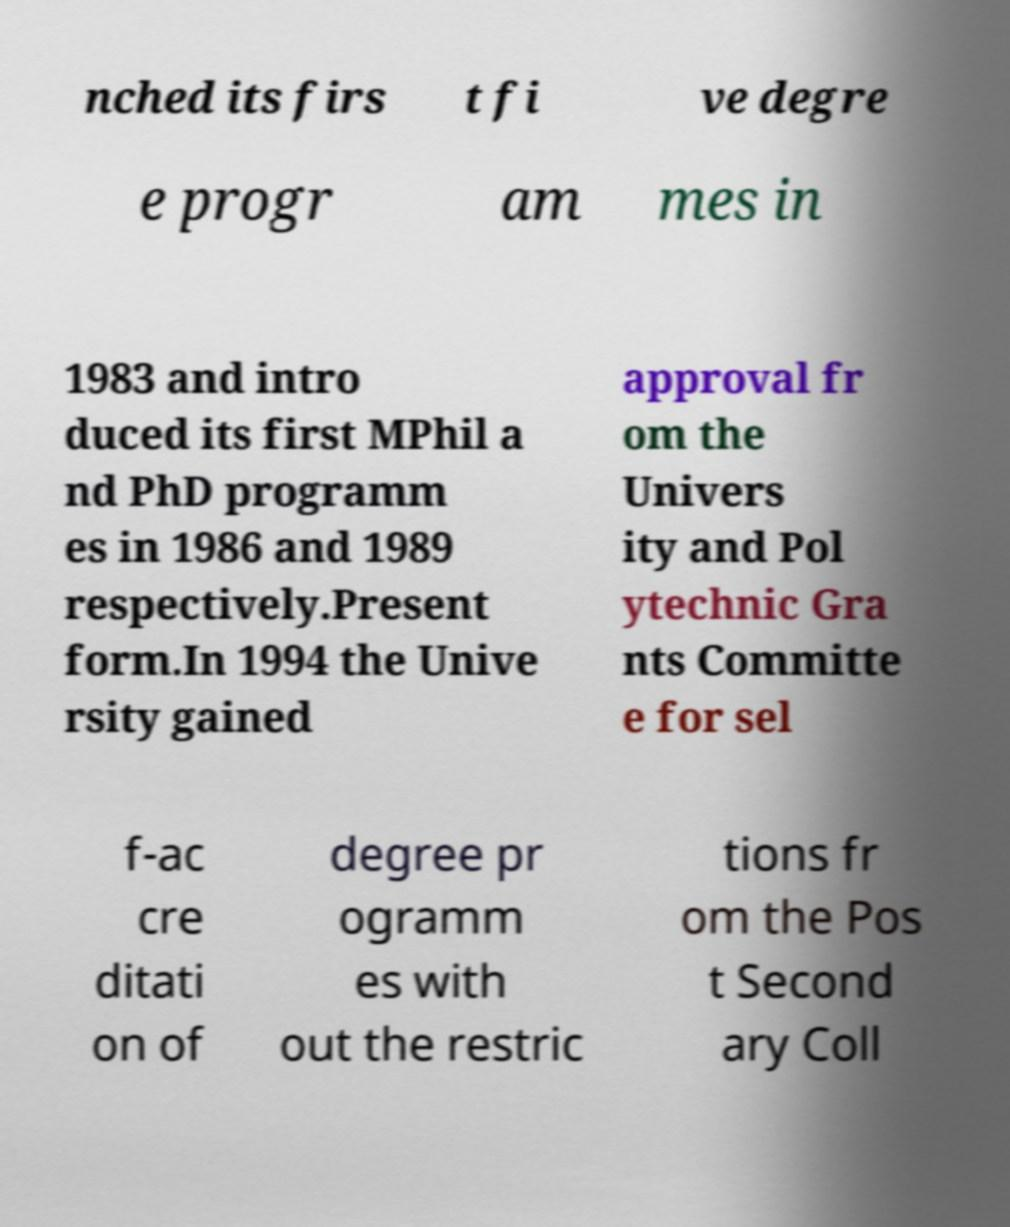Please identify and transcribe the text found in this image. nched its firs t fi ve degre e progr am mes in 1983 and intro duced its first MPhil a nd PhD programm es in 1986 and 1989 respectively.Present form.In 1994 the Unive rsity gained approval fr om the Univers ity and Pol ytechnic Gra nts Committe e for sel f-ac cre ditati on of degree pr ogramm es with out the restric tions fr om the Pos t Second ary Coll 